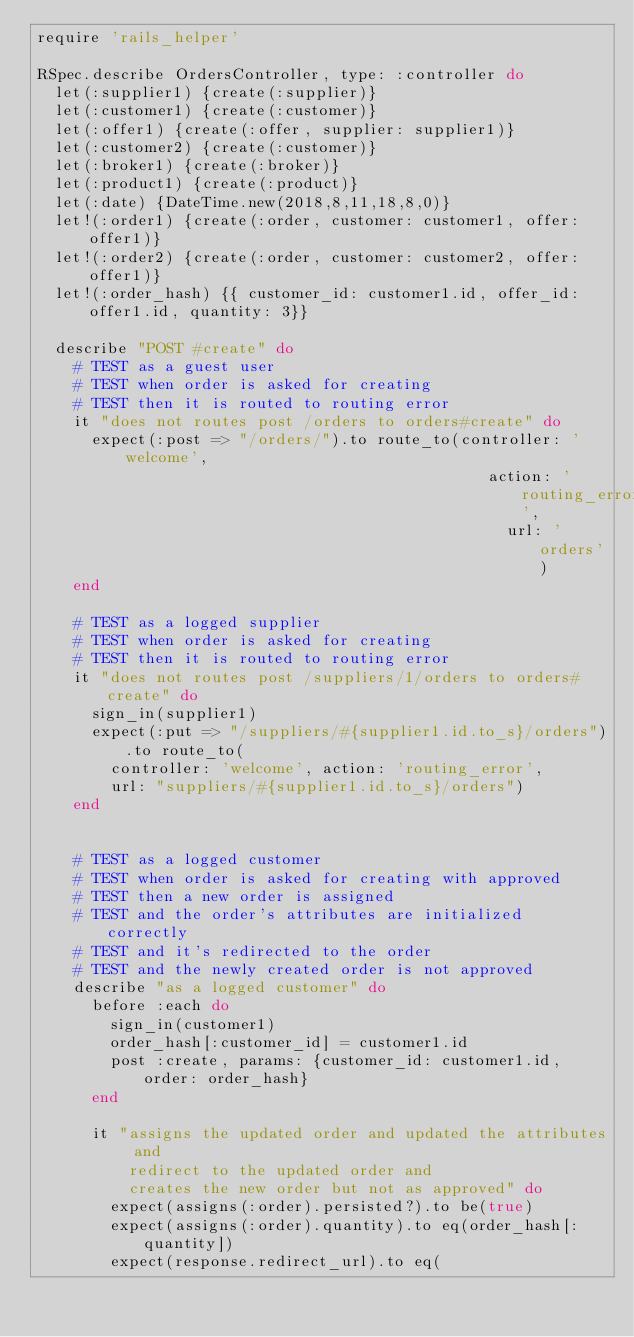Convert code to text. <code><loc_0><loc_0><loc_500><loc_500><_Ruby_>require 'rails_helper'

RSpec.describe OrdersController, type: :controller do
  let(:supplier1) {create(:supplier)}
  let(:customer1) {create(:customer)}
  let(:offer1) {create(:offer, supplier: supplier1)}
  let(:customer2) {create(:customer)}
  let(:broker1) {create(:broker)}
  let(:product1) {create(:product)}
  let(:date) {DateTime.new(2018,8,11,18,8,0)}
  let!(:order1) {create(:order, customer: customer1, offer: offer1)}
  let!(:order2) {create(:order, customer: customer2, offer: offer1)}
  let!(:order_hash) {{ customer_id: customer1.id, offer_id: offer1.id, quantity: 3}}

  describe "POST #create" do
    # TEST as a guest user
    # TEST when order is asked for creating
    # TEST then it is routed to routing error
    it "does not routes post /orders to orders#create" do
      expect(:post => "/orders/").to route_to(controller: 'welcome',
                                                 action: 'routing_error',
                                                   url: 'orders')
    end

    # TEST as a logged supplier
    # TEST when order is asked for creating
    # TEST then it is routed to routing error
    it "does not routes post /suppliers/1/orders to orders#create" do
      sign_in(supplier1)
      expect(:put => "/suppliers/#{supplier1.id.to_s}/orders").to route_to(
        controller: 'welcome', action: 'routing_error',
        url: "suppliers/#{supplier1.id.to_s}/orders")
    end


    # TEST as a logged customer
    # TEST when order is asked for creating with approved
    # TEST then a new order is assigned
    # TEST and the order's attributes are initialized correctly
    # TEST and it's redirected to the order
    # TEST and the newly created order is not approved
    describe "as a logged customer" do
      before :each do
        sign_in(customer1)
        order_hash[:customer_id] = customer1.id
        post :create, params: {customer_id: customer1.id, order: order_hash}
      end

      it "assigns the updated order and updated the attributes and
          redirect to the updated order and
          creates the new order but not as approved" do
        expect(assigns(:order).persisted?).to be(true)
        expect(assigns(:order).quantity).to eq(order_hash[:quantity])
        expect(response.redirect_url).to eq(</code> 